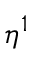<formula> <loc_0><loc_0><loc_500><loc_500>\eta ^ { 1 }</formula> 